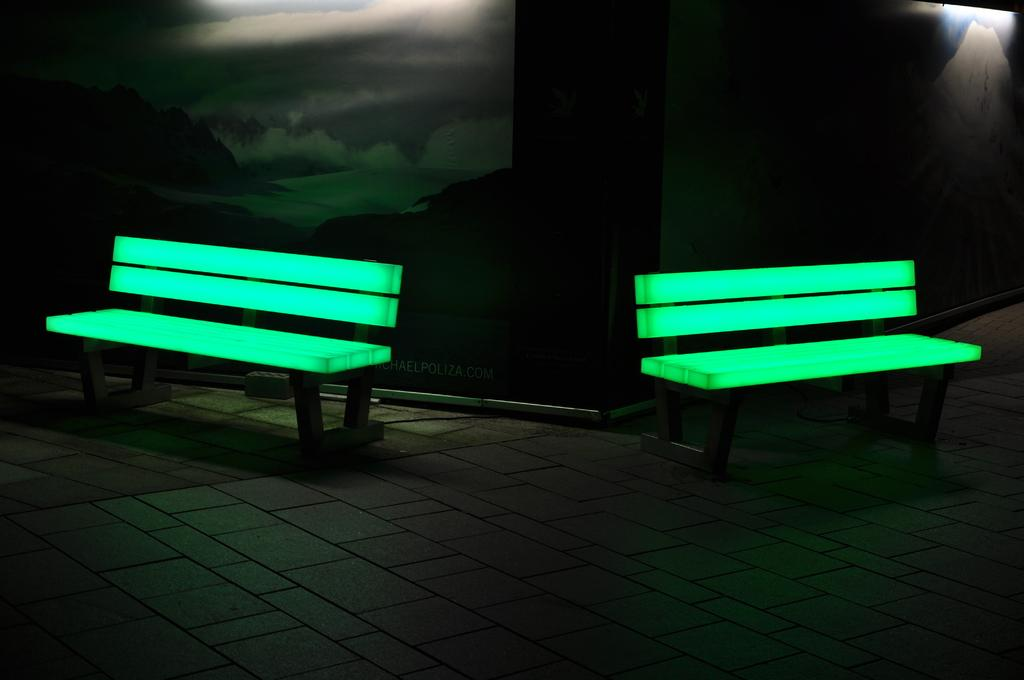How many benches are visible in the image? There are two benches in the image. What can be seen on the walls in the image? There are posters on the walls. Can you describe one of the posters? One of the posters depicts hills and a lake. What type of lumber is being used to construct the benches in the image? There is no information about the construction of the benches in the image, nor is there any lumber visible. 